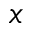Convert formula to latex. <formula><loc_0><loc_0><loc_500><loc_500>x</formula> 